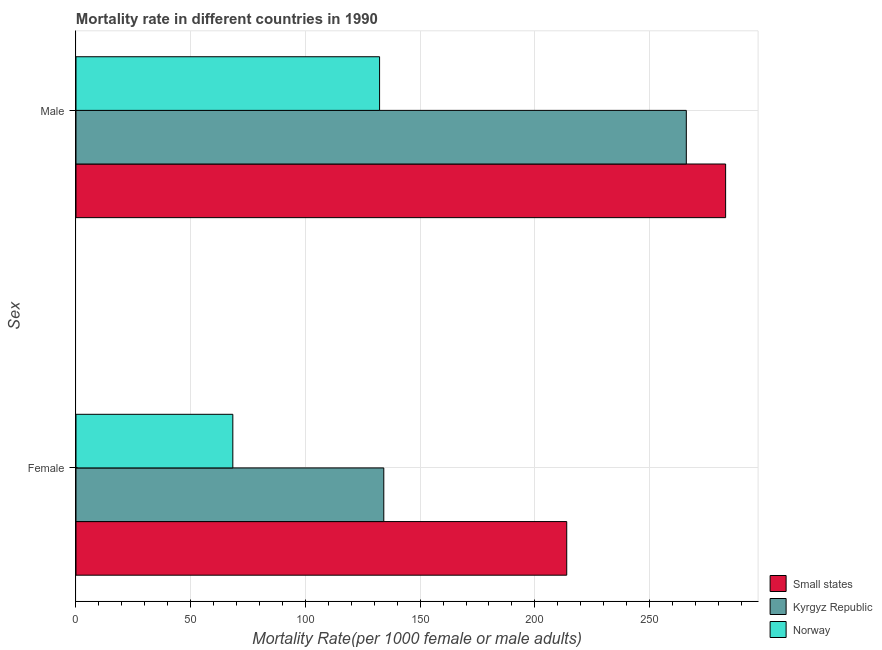How many different coloured bars are there?
Provide a succinct answer. 3. How many bars are there on the 1st tick from the bottom?
Provide a short and direct response. 3. What is the label of the 2nd group of bars from the top?
Your answer should be compact. Female. What is the male mortality rate in Norway?
Keep it short and to the point. 132.32. Across all countries, what is the maximum male mortality rate?
Offer a very short reply. 283.14. Across all countries, what is the minimum female mortality rate?
Make the answer very short. 68.36. In which country was the male mortality rate maximum?
Your response must be concise. Small states. In which country was the male mortality rate minimum?
Provide a short and direct response. Norway. What is the total male mortality rate in the graph?
Keep it short and to the point. 681.47. What is the difference between the female mortality rate in Small states and that in Norway?
Your response must be concise. 145.53. What is the difference between the female mortality rate in Kyrgyz Republic and the male mortality rate in Small states?
Your answer should be compact. -148.99. What is the average female mortality rate per country?
Ensure brevity in your answer.  138.8. What is the difference between the male mortality rate and female mortality rate in Kyrgyz Republic?
Offer a very short reply. 131.86. What is the ratio of the male mortality rate in Norway to that in Small states?
Provide a succinct answer. 0.47. Is the male mortality rate in Norway less than that in Small states?
Your response must be concise. Yes. In how many countries, is the male mortality rate greater than the average male mortality rate taken over all countries?
Make the answer very short. 2. What does the 2nd bar from the top in Female represents?
Offer a very short reply. Kyrgyz Republic. What does the 1st bar from the bottom in Female represents?
Keep it short and to the point. Small states. Are all the bars in the graph horizontal?
Provide a succinct answer. Yes. What is the difference between two consecutive major ticks on the X-axis?
Provide a succinct answer. 50. Are the values on the major ticks of X-axis written in scientific E-notation?
Your response must be concise. No. Does the graph contain any zero values?
Provide a short and direct response. No. Where does the legend appear in the graph?
Your answer should be very brief. Bottom right. How many legend labels are there?
Provide a short and direct response. 3. How are the legend labels stacked?
Your answer should be very brief. Vertical. What is the title of the graph?
Keep it short and to the point. Mortality rate in different countries in 1990. Does "Montenegro" appear as one of the legend labels in the graph?
Keep it short and to the point. No. What is the label or title of the X-axis?
Offer a terse response. Mortality Rate(per 1000 female or male adults). What is the label or title of the Y-axis?
Offer a terse response. Sex. What is the Mortality Rate(per 1000 female or male adults) in Small states in Female?
Offer a very short reply. 213.89. What is the Mortality Rate(per 1000 female or male adults) of Kyrgyz Republic in Female?
Offer a very short reply. 134.15. What is the Mortality Rate(per 1000 female or male adults) of Norway in Female?
Give a very brief answer. 68.36. What is the Mortality Rate(per 1000 female or male adults) of Small states in Male?
Your answer should be compact. 283.14. What is the Mortality Rate(per 1000 female or male adults) of Kyrgyz Republic in Male?
Your response must be concise. 266.01. What is the Mortality Rate(per 1000 female or male adults) in Norway in Male?
Provide a succinct answer. 132.32. Across all Sex, what is the maximum Mortality Rate(per 1000 female or male adults) in Small states?
Keep it short and to the point. 283.14. Across all Sex, what is the maximum Mortality Rate(per 1000 female or male adults) of Kyrgyz Republic?
Make the answer very short. 266.01. Across all Sex, what is the maximum Mortality Rate(per 1000 female or male adults) in Norway?
Provide a succinct answer. 132.32. Across all Sex, what is the minimum Mortality Rate(per 1000 female or male adults) of Small states?
Make the answer very short. 213.89. Across all Sex, what is the minimum Mortality Rate(per 1000 female or male adults) of Kyrgyz Republic?
Your answer should be very brief. 134.15. Across all Sex, what is the minimum Mortality Rate(per 1000 female or male adults) in Norway?
Provide a succinct answer. 68.36. What is the total Mortality Rate(per 1000 female or male adults) in Small states in the graph?
Provide a succinct answer. 497.03. What is the total Mortality Rate(per 1000 female or male adults) of Kyrgyz Republic in the graph?
Your answer should be very brief. 400.17. What is the total Mortality Rate(per 1000 female or male adults) in Norway in the graph?
Offer a terse response. 200.68. What is the difference between the Mortality Rate(per 1000 female or male adults) of Small states in Female and that in Male?
Ensure brevity in your answer.  -69.25. What is the difference between the Mortality Rate(per 1000 female or male adults) in Kyrgyz Republic in Female and that in Male?
Your answer should be very brief. -131.86. What is the difference between the Mortality Rate(per 1000 female or male adults) of Norway in Female and that in Male?
Offer a very short reply. -63.96. What is the difference between the Mortality Rate(per 1000 female or male adults) of Small states in Female and the Mortality Rate(per 1000 female or male adults) of Kyrgyz Republic in Male?
Provide a short and direct response. -52.12. What is the difference between the Mortality Rate(per 1000 female or male adults) in Small states in Female and the Mortality Rate(per 1000 female or male adults) in Norway in Male?
Provide a succinct answer. 81.57. What is the difference between the Mortality Rate(per 1000 female or male adults) in Kyrgyz Republic in Female and the Mortality Rate(per 1000 female or male adults) in Norway in Male?
Provide a succinct answer. 1.84. What is the average Mortality Rate(per 1000 female or male adults) of Small states per Sex?
Your response must be concise. 248.51. What is the average Mortality Rate(per 1000 female or male adults) of Kyrgyz Republic per Sex?
Ensure brevity in your answer.  200.08. What is the average Mortality Rate(per 1000 female or male adults) in Norway per Sex?
Your response must be concise. 100.34. What is the difference between the Mortality Rate(per 1000 female or male adults) of Small states and Mortality Rate(per 1000 female or male adults) of Kyrgyz Republic in Female?
Keep it short and to the point. 79.73. What is the difference between the Mortality Rate(per 1000 female or male adults) in Small states and Mortality Rate(per 1000 female or male adults) in Norway in Female?
Give a very brief answer. 145.53. What is the difference between the Mortality Rate(per 1000 female or male adults) in Kyrgyz Republic and Mortality Rate(per 1000 female or male adults) in Norway in Female?
Keep it short and to the point. 65.8. What is the difference between the Mortality Rate(per 1000 female or male adults) in Small states and Mortality Rate(per 1000 female or male adults) in Kyrgyz Republic in Male?
Your response must be concise. 17.13. What is the difference between the Mortality Rate(per 1000 female or male adults) of Small states and Mortality Rate(per 1000 female or male adults) of Norway in Male?
Give a very brief answer. 150.82. What is the difference between the Mortality Rate(per 1000 female or male adults) in Kyrgyz Republic and Mortality Rate(per 1000 female or male adults) in Norway in Male?
Ensure brevity in your answer.  133.69. What is the ratio of the Mortality Rate(per 1000 female or male adults) of Small states in Female to that in Male?
Keep it short and to the point. 0.76. What is the ratio of the Mortality Rate(per 1000 female or male adults) of Kyrgyz Republic in Female to that in Male?
Provide a short and direct response. 0.5. What is the ratio of the Mortality Rate(per 1000 female or male adults) in Norway in Female to that in Male?
Provide a short and direct response. 0.52. What is the difference between the highest and the second highest Mortality Rate(per 1000 female or male adults) in Small states?
Provide a succinct answer. 69.25. What is the difference between the highest and the second highest Mortality Rate(per 1000 female or male adults) of Kyrgyz Republic?
Provide a short and direct response. 131.86. What is the difference between the highest and the second highest Mortality Rate(per 1000 female or male adults) of Norway?
Provide a short and direct response. 63.96. What is the difference between the highest and the lowest Mortality Rate(per 1000 female or male adults) in Small states?
Ensure brevity in your answer.  69.25. What is the difference between the highest and the lowest Mortality Rate(per 1000 female or male adults) in Kyrgyz Republic?
Keep it short and to the point. 131.86. What is the difference between the highest and the lowest Mortality Rate(per 1000 female or male adults) in Norway?
Offer a very short reply. 63.96. 